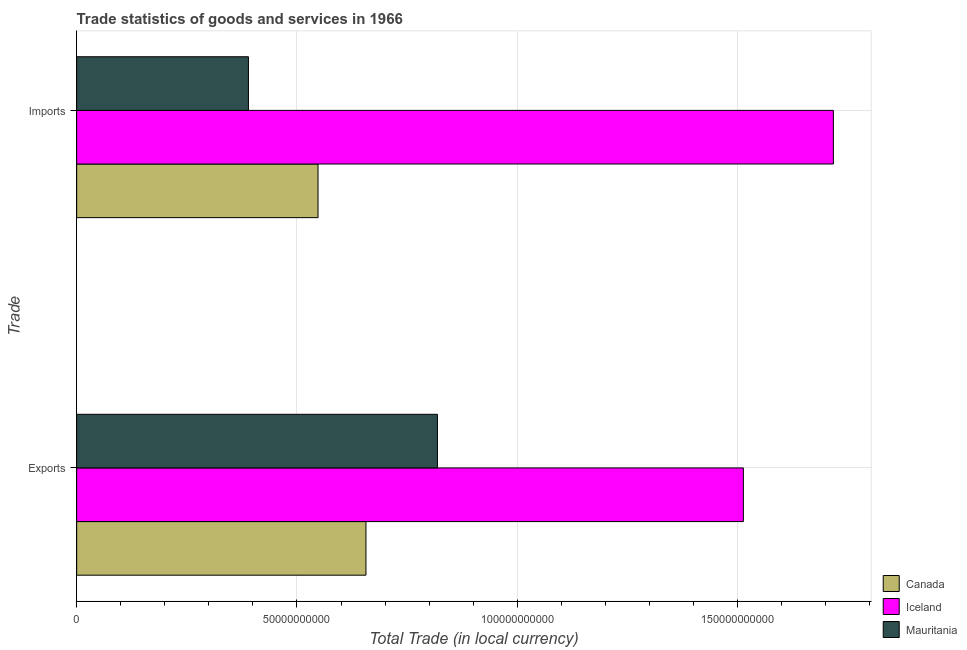How many different coloured bars are there?
Provide a succinct answer. 3. Are the number of bars on each tick of the Y-axis equal?
Keep it short and to the point. Yes. How many bars are there on the 2nd tick from the top?
Provide a short and direct response. 3. How many bars are there on the 1st tick from the bottom?
Ensure brevity in your answer.  3. What is the label of the 1st group of bars from the top?
Provide a succinct answer. Imports. What is the imports of goods and services in Iceland?
Ensure brevity in your answer.  1.72e+11. Across all countries, what is the maximum export of goods and services?
Offer a terse response. 1.51e+11. Across all countries, what is the minimum imports of goods and services?
Your answer should be very brief. 3.90e+1. What is the total imports of goods and services in the graph?
Offer a very short reply. 2.65e+11. What is the difference between the imports of goods and services in Mauritania and that in Canada?
Provide a short and direct response. -1.58e+1. What is the difference between the imports of goods and services in Mauritania and the export of goods and services in Canada?
Your answer should be compact. -2.67e+1. What is the average export of goods and services per country?
Your answer should be compact. 9.96e+1. What is the difference between the imports of goods and services and export of goods and services in Canada?
Your response must be concise. -1.09e+1. In how many countries, is the export of goods and services greater than 30000000000 LCU?
Offer a terse response. 3. What is the ratio of the export of goods and services in Mauritania to that in Canada?
Keep it short and to the point. 1.25. Is the imports of goods and services in Canada less than that in Iceland?
Your answer should be compact. Yes. What does the 1st bar from the top in Exports represents?
Provide a short and direct response. Mauritania. How many bars are there?
Your response must be concise. 6. Are all the bars in the graph horizontal?
Your response must be concise. Yes. What is the difference between two consecutive major ticks on the X-axis?
Give a very brief answer. 5.00e+1. Are the values on the major ticks of X-axis written in scientific E-notation?
Your answer should be compact. No. Does the graph contain any zero values?
Give a very brief answer. No. Does the graph contain grids?
Your response must be concise. Yes. How many legend labels are there?
Your answer should be compact. 3. How are the legend labels stacked?
Ensure brevity in your answer.  Vertical. What is the title of the graph?
Offer a terse response. Trade statistics of goods and services in 1966. Does "Low income" appear as one of the legend labels in the graph?
Give a very brief answer. No. What is the label or title of the X-axis?
Make the answer very short. Total Trade (in local currency). What is the label or title of the Y-axis?
Provide a short and direct response. Trade. What is the Total Trade (in local currency) in Canada in Exports?
Your answer should be compact. 6.57e+1. What is the Total Trade (in local currency) in Iceland in Exports?
Offer a very short reply. 1.51e+11. What is the Total Trade (in local currency) of Mauritania in Exports?
Your answer should be compact. 8.19e+1. What is the Total Trade (in local currency) of Canada in Imports?
Your answer should be compact. 5.48e+1. What is the Total Trade (in local currency) in Iceland in Imports?
Provide a short and direct response. 1.72e+11. What is the Total Trade (in local currency) in Mauritania in Imports?
Give a very brief answer. 3.90e+1. Across all Trade, what is the maximum Total Trade (in local currency) of Canada?
Offer a terse response. 6.57e+1. Across all Trade, what is the maximum Total Trade (in local currency) of Iceland?
Your answer should be very brief. 1.72e+11. Across all Trade, what is the maximum Total Trade (in local currency) in Mauritania?
Your answer should be very brief. 8.19e+1. Across all Trade, what is the minimum Total Trade (in local currency) in Canada?
Your answer should be compact. 5.48e+1. Across all Trade, what is the minimum Total Trade (in local currency) in Iceland?
Provide a succinct answer. 1.51e+11. Across all Trade, what is the minimum Total Trade (in local currency) of Mauritania?
Your response must be concise. 3.90e+1. What is the total Total Trade (in local currency) of Canada in the graph?
Ensure brevity in your answer.  1.20e+11. What is the total Total Trade (in local currency) in Iceland in the graph?
Your answer should be very brief. 3.23e+11. What is the total Total Trade (in local currency) of Mauritania in the graph?
Offer a terse response. 1.21e+11. What is the difference between the Total Trade (in local currency) in Canada in Exports and that in Imports?
Keep it short and to the point. 1.09e+1. What is the difference between the Total Trade (in local currency) of Iceland in Exports and that in Imports?
Your answer should be very brief. -2.04e+1. What is the difference between the Total Trade (in local currency) in Mauritania in Exports and that in Imports?
Your answer should be compact. 4.29e+1. What is the difference between the Total Trade (in local currency) in Canada in Exports and the Total Trade (in local currency) in Iceland in Imports?
Your answer should be compact. -1.06e+11. What is the difference between the Total Trade (in local currency) of Canada in Exports and the Total Trade (in local currency) of Mauritania in Imports?
Make the answer very short. 2.67e+1. What is the difference between the Total Trade (in local currency) in Iceland in Exports and the Total Trade (in local currency) in Mauritania in Imports?
Your answer should be very brief. 1.12e+11. What is the average Total Trade (in local currency) in Canada per Trade?
Give a very brief answer. 6.02e+1. What is the average Total Trade (in local currency) in Iceland per Trade?
Ensure brevity in your answer.  1.62e+11. What is the average Total Trade (in local currency) of Mauritania per Trade?
Your response must be concise. 6.04e+1. What is the difference between the Total Trade (in local currency) of Canada and Total Trade (in local currency) of Iceland in Exports?
Provide a short and direct response. -8.56e+1. What is the difference between the Total Trade (in local currency) in Canada and Total Trade (in local currency) in Mauritania in Exports?
Provide a succinct answer. -1.62e+1. What is the difference between the Total Trade (in local currency) in Iceland and Total Trade (in local currency) in Mauritania in Exports?
Ensure brevity in your answer.  6.94e+1. What is the difference between the Total Trade (in local currency) in Canada and Total Trade (in local currency) in Iceland in Imports?
Make the answer very short. -1.17e+11. What is the difference between the Total Trade (in local currency) in Canada and Total Trade (in local currency) in Mauritania in Imports?
Offer a terse response. 1.58e+1. What is the difference between the Total Trade (in local currency) in Iceland and Total Trade (in local currency) in Mauritania in Imports?
Offer a terse response. 1.33e+11. What is the ratio of the Total Trade (in local currency) of Canada in Exports to that in Imports?
Your response must be concise. 1.2. What is the ratio of the Total Trade (in local currency) of Iceland in Exports to that in Imports?
Offer a terse response. 0.88. What is the ratio of the Total Trade (in local currency) in Mauritania in Exports to that in Imports?
Offer a very short reply. 2.1. What is the difference between the highest and the second highest Total Trade (in local currency) in Canada?
Offer a terse response. 1.09e+1. What is the difference between the highest and the second highest Total Trade (in local currency) of Iceland?
Provide a succinct answer. 2.04e+1. What is the difference between the highest and the second highest Total Trade (in local currency) of Mauritania?
Your answer should be compact. 4.29e+1. What is the difference between the highest and the lowest Total Trade (in local currency) of Canada?
Your answer should be very brief. 1.09e+1. What is the difference between the highest and the lowest Total Trade (in local currency) of Iceland?
Offer a terse response. 2.04e+1. What is the difference between the highest and the lowest Total Trade (in local currency) of Mauritania?
Your response must be concise. 4.29e+1. 